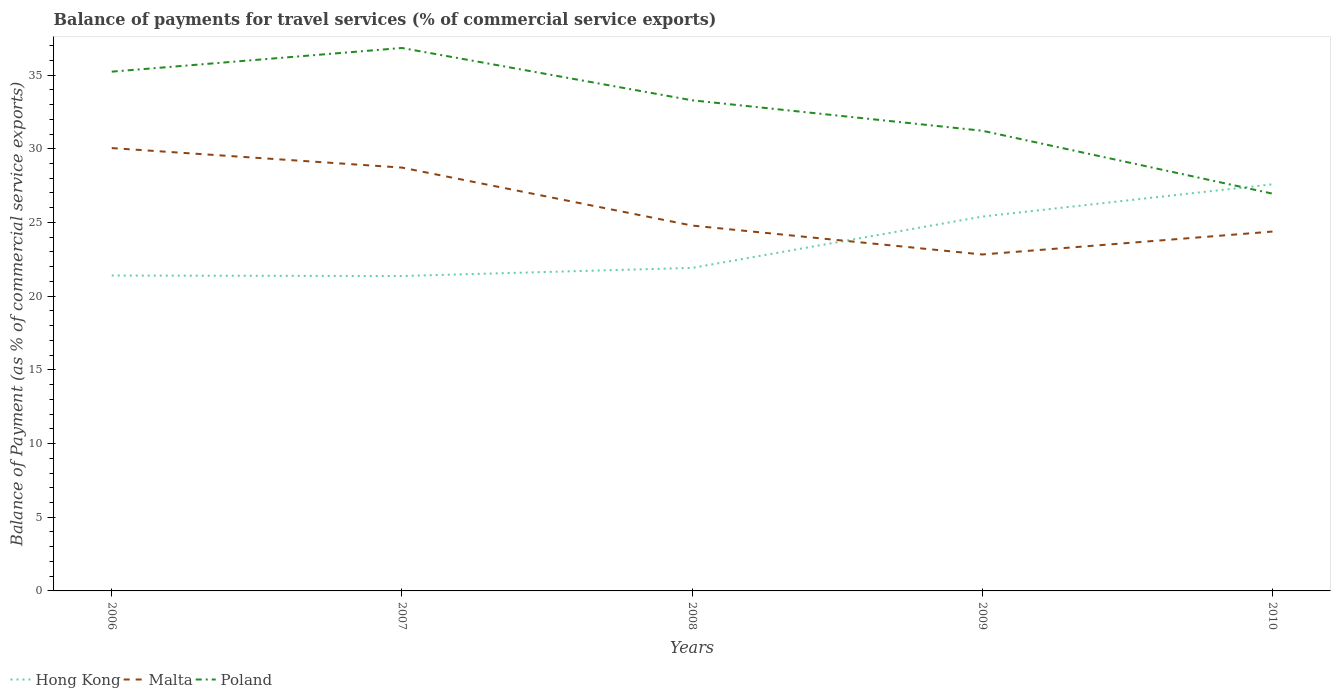Across all years, what is the maximum balance of payments for travel services in Malta?
Offer a very short reply. 22.83. In which year was the balance of payments for travel services in Poland maximum?
Provide a short and direct response. 2010. What is the total balance of payments for travel services in Hong Kong in the graph?
Give a very brief answer. 0.03. What is the difference between the highest and the second highest balance of payments for travel services in Hong Kong?
Provide a short and direct response. 6.22. Is the balance of payments for travel services in Hong Kong strictly greater than the balance of payments for travel services in Malta over the years?
Provide a short and direct response. No. How many lines are there?
Your answer should be very brief. 3. How many years are there in the graph?
Keep it short and to the point. 5. Are the values on the major ticks of Y-axis written in scientific E-notation?
Keep it short and to the point. No. Does the graph contain any zero values?
Your response must be concise. No. Where does the legend appear in the graph?
Ensure brevity in your answer.  Bottom left. How many legend labels are there?
Provide a succinct answer. 3. How are the legend labels stacked?
Provide a succinct answer. Horizontal. What is the title of the graph?
Keep it short and to the point. Balance of payments for travel services (% of commercial service exports). Does "Isle of Man" appear as one of the legend labels in the graph?
Offer a terse response. No. What is the label or title of the X-axis?
Offer a terse response. Years. What is the label or title of the Y-axis?
Provide a succinct answer. Balance of Payment (as % of commercial service exports). What is the Balance of Payment (as % of commercial service exports) of Hong Kong in 2006?
Give a very brief answer. 21.4. What is the Balance of Payment (as % of commercial service exports) of Malta in 2006?
Offer a very short reply. 30.05. What is the Balance of Payment (as % of commercial service exports) of Poland in 2006?
Your response must be concise. 35.23. What is the Balance of Payment (as % of commercial service exports) in Hong Kong in 2007?
Your response must be concise. 21.37. What is the Balance of Payment (as % of commercial service exports) of Malta in 2007?
Provide a succinct answer. 28.72. What is the Balance of Payment (as % of commercial service exports) in Poland in 2007?
Give a very brief answer. 36.84. What is the Balance of Payment (as % of commercial service exports) in Hong Kong in 2008?
Your answer should be compact. 21.92. What is the Balance of Payment (as % of commercial service exports) in Malta in 2008?
Offer a very short reply. 24.79. What is the Balance of Payment (as % of commercial service exports) in Poland in 2008?
Offer a terse response. 33.29. What is the Balance of Payment (as % of commercial service exports) in Hong Kong in 2009?
Provide a succinct answer. 25.4. What is the Balance of Payment (as % of commercial service exports) of Malta in 2009?
Ensure brevity in your answer.  22.83. What is the Balance of Payment (as % of commercial service exports) in Poland in 2009?
Make the answer very short. 31.22. What is the Balance of Payment (as % of commercial service exports) of Hong Kong in 2010?
Make the answer very short. 27.59. What is the Balance of Payment (as % of commercial service exports) in Malta in 2010?
Your response must be concise. 24.38. What is the Balance of Payment (as % of commercial service exports) of Poland in 2010?
Offer a terse response. 26.95. Across all years, what is the maximum Balance of Payment (as % of commercial service exports) of Hong Kong?
Keep it short and to the point. 27.59. Across all years, what is the maximum Balance of Payment (as % of commercial service exports) of Malta?
Give a very brief answer. 30.05. Across all years, what is the maximum Balance of Payment (as % of commercial service exports) of Poland?
Ensure brevity in your answer.  36.84. Across all years, what is the minimum Balance of Payment (as % of commercial service exports) of Hong Kong?
Provide a succinct answer. 21.37. Across all years, what is the minimum Balance of Payment (as % of commercial service exports) in Malta?
Make the answer very short. 22.83. Across all years, what is the minimum Balance of Payment (as % of commercial service exports) of Poland?
Your response must be concise. 26.95. What is the total Balance of Payment (as % of commercial service exports) in Hong Kong in the graph?
Give a very brief answer. 117.67. What is the total Balance of Payment (as % of commercial service exports) of Malta in the graph?
Your answer should be compact. 130.76. What is the total Balance of Payment (as % of commercial service exports) in Poland in the graph?
Make the answer very short. 163.54. What is the difference between the Balance of Payment (as % of commercial service exports) of Hong Kong in 2006 and that in 2007?
Provide a short and direct response. 0.03. What is the difference between the Balance of Payment (as % of commercial service exports) in Malta in 2006 and that in 2007?
Provide a short and direct response. 1.32. What is the difference between the Balance of Payment (as % of commercial service exports) of Poland in 2006 and that in 2007?
Give a very brief answer. -1.61. What is the difference between the Balance of Payment (as % of commercial service exports) of Hong Kong in 2006 and that in 2008?
Your response must be concise. -0.52. What is the difference between the Balance of Payment (as % of commercial service exports) in Malta in 2006 and that in 2008?
Keep it short and to the point. 5.26. What is the difference between the Balance of Payment (as % of commercial service exports) of Poland in 2006 and that in 2008?
Offer a very short reply. 1.94. What is the difference between the Balance of Payment (as % of commercial service exports) of Hong Kong in 2006 and that in 2009?
Your answer should be very brief. -4. What is the difference between the Balance of Payment (as % of commercial service exports) in Malta in 2006 and that in 2009?
Provide a succinct answer. 7.22. What is the difference between the Balance of Payment (as % of commercial service exports) of Poland in 2006 and that in 2009?
Keep it short and to the point. 4.01. What is the difference between the Balance of Payment (as % of commercial service exports) in Hong Kong in 2006 and that in 2010?
Keep it short and to the point. -6.19. What is the difference between the Balance of Payment (as % of commercial service exports) in Malta in 2006 and that in 2010?
Offer a very short reply. 5.66. What is the difference between the Balance of Payment (as % of commercial service exports) in Poland in 2006 and that in 2010?
Give a very brief answer. 8.28. What is the difference between the Balance of Payment (as % of commercial service exports) in Hong Kong in 2007 and that in 2008?
Make the answer very short. -0.55. What is the difference between the Balance of Payment (as % of commercial service exports) in Malta in 2007 and that in 2008?
Your answer should be compact. 3.93. What is the difference between the Balance of Payment (as % of commercial service exports) of Poland in 2007 and that in 2008?
Your response must be concise. 3.55. What is the difference between the Balance of Payment (as % of commercial service exports) of Hong Kong in 2007 and that in 2009?
Give a very brief answer. -4.03. What is the difference between the Balance of Payment (as % of commercial service exports) of Malta in 2007 and that in 2009?
Make the answer very short. 5.9. What is the difference between the Balance of Payment (as % of commercial service exports) in Poland in 2007 and that in 2009?
Provide a short and direct response. 5.61. What is the difference between the Balance of Payment (as % of commercial service exports) in Hong Kong in 2007 and that in 2010?
Give a very brief answer. -6.22. What is the difference between the Balance of Payment (as % of commercial service exports) in Malta in 2007 and that in 2010?
Your response must be concise. 4.34. What is the difference between the Balance of Payment (as % of commercial service exports) of Poland in 2007 and that in 2010?
Your answer should be very brief. 9.88. What is the difference between the Balance of Payment (as % of commercial service exports) of Hong Kong in 2008 and that in 2009?
Ensure brevity in your answer.  -3.48. What is the difference between the Balance of Payment (as % of commercial service exports) in Malta in 2008 and that in 2009?
Ensure brevity in your answer.  1.96. What is the difference between the Balance of Payment (as % of commercial service exports) in Poland in 2008 and that in 2009?
Make the answer very short. 2.06. What is the difference between the Balance of Payment (as % of commercial service exports) of Hong Kong in 2008 and that in 2010?
Provide a succinct answer. -5.67. What is the difference between the Balance of Payment (as % of commercial service exports) of Malta in 2008 and that in 2010?
Provide a short and direct response. 0.41. What is the difference between the Balance of Payment (as % of commercial service exports) in Poland in 2008 and that in 2010?
Ensure brevity in your answer.  6.33. What is the difference between the Balance of Payment (as % of commercial service exports) of Hong Kong in 2009 and that in 2010?
Offer a terse response. -2.19. What is the difference between the Balance of Payment (as % of commercial service exports) in Malta in 2009 and that in 2010?
Offer a terse response. -1.55. What is the difference between the Balance of Payment (as % of commercial service exports) in Poland in 2009 and that in 2010?
Provide a short and direct response. 4.27. What is the difference between the Balance of Payment (as % of commercial service exports) in Hong Kong in 2006 and the Balance of Payment (as % of commercial service exports) in Malta in 2007?
Your answer should be compact. -7.32. What is the difference between the Balance of Payment (as % of commercial service exports) of Hong Kong in 2006 and the Balance of Payment (as % of commercial service exports) of Poland in 2007?
Give a very brief answer. -15.44. What is the difference between the Balance of Payment (as % of commercial service exports) of Malta in 2006 and the Balance of Payment (as % of commercial service exports) of Poland in 2007?
Make the answer very short. -6.79. What is the difference between the Balance of Payment (as % of commercial service exports) in Hong Kong in 2006 and the Balance of Payment (as % of commercial service exports) in Malta in 2008?
Give a very brief answer. -3.39. What is the difference between the Balance of Payment (as % of commercial service exports) of Hong Kong in 2006 and the Balance of Payment (as % of commercial service exports) of Poland in 2008?
Keep it short and to the point. -11.89. What is the difference between the Balance of Payment (as % of commercial service exports) in Malta in 2006 and the Balance of Payment (as % of commercial service exports) in Poland in 2008?
Provide a short and direct response. -3.24. What is the difference between the Balance of Payment (as % of commercial service exports) of Hong Kong in 2006 and the Balance of Payment (as % of commercial service exports) of Malta in 2009?
Your answer should be very brief. -1.43. What is the difference between the Balance of Payment (as % of commercial service exports) in Hong Kong in 2006 and the Balance of Payment (as % of commercial service exports) in Poland in 2009?
Your answer should be very brief. -9.82. What is the difference between the Balance of Payment (as % of commercial service exports) of Malta in 2006 and the Balance of Payment (as % of commercial service exports) of Poland in 2009?
Make the answer very short. -1.18. What is the difference between the Balance of Payment (as % of commercial service exports) of Hong Kong in 2006 and the Balance of Payment (as % of commercial service exports) of Malta in 2010?
Offer a terse response. -2.98. What is the difference between the Balance of Payment (as % of commercial service exports) of Hong Kong in 2006 and the Balance of Payment (as % of commercial service exports) of Poland in 2010?
Make the answer very short. -5.56. What is the difference between the Balance of Payment (as % of commercial service exports) of Malta in 2006 and the Balance of Payment (as % of commercial service exports) of Poland in 2010?
Your answer should be compact. 3.09. What is the difference between the Balance of Payment (as % of commercial service exports) of Hong Kong in 2007 and the Balance of Payment (as % of commercial service exports) of Malta in 2008?
Make the answer very short. -3.42. What is the difference between the Balance of Payment (as % of commercial service exports) of Hong Kong in 2007 and the Balance of Payment (as % of commercial service exports) of Poland in 2008?
Keep it short and to the point. -11.92. What is the difference between the Balance of Payment (as % of commercial service exports) of Malta in 2007 and the Balance of Payment (as % of commercial service exports) of Poland in 2008?
Your response must be concise. -4.57. What is the difference between the Balance of Payment (as % of commercial service exports) in Hong Kong in 2007 and the Balance of Payment (as % of commercial service exports) in Malta in 2009?
Your response must be concise. -1.46. What is the difference between the Balance of Payment (as % of commercial service exports) of Hong Kong in 2007 and the Balance of Payment (as % of commercial service exports) of Poland in 2009?
Offer a very short reply. -9.86. What is the difference between the Balance of Payment (as % of commercial service exports) in Malta in 2007 and the Balance of Payment (as % of commercial service exports) in Poland in 2009?
Ensure brevity in your answer.  -2.5. What is the difference between the Balance of Payment (as % of commercial service exports) in Hong Kong in 2007 and the Balance of Payment (as % of commercial service exports) in Malta in 2010?
Your response must be concise. -3.02. What is the difference between the Balance of Payment (as % of commercial service exports) in Hong Kong in 2007 and the Balance of Payment (as % of commercial service exports) in Poland in 2010?
Keep it short and to the point. -5.59. What is the difference between the Balance of Payment (as % of commercial service exports) in Malta in 2007 and the Balance of Payment (as % of commercial service exports) in Poland in 2010?
Your response must be concise. 1.77. What is the difference between the Balance of Payment (as % of commercial service exports) in Hong Kong in 2008 and the Balance of Payment (as % of commercial service exports) in Malta in 2009?
Provide a succinct answer. -0.91. What is the difference between the Balance of Payment (as % of commercial service exports) of Hong Kong in 2008 and the Balance of Payment (as % of commercial service exports) of Poland in 2009?
Offer a very short reply. -9.31. What is the difference between the Balance of Payment (as % of commercial service exports) in Malta in 2008 and the Balance of Payment (as % of commercial service exports) in Poland in 2009?
Provide a succinct answer. -6.43. What is the difference between the Balance of Payment (as % of commercial service exports) in Hong Kong in 2008 and the Balance of Payment (as % of commercial service exports) in Malta in 2010?
Offer a terse response. -2.46. What is the difference between the Balance of Payment (as % of commercial service exports) in Hong Kong in 2008 and the Balance of Payment (as % of commercial service exports) in Poland in 2010?
Your answer should be very brief. -5.04. What is the difference between the Balance of Payment (as % of commercial service exports) of Malta in 2008 and the Balance of Payment (as % of commercial service exports) of Poland in 2010?
Offer a very short reply. -2.17. What is the difference between the Balance of Payment (as % of commercial service exports) in Hong Kong in 2009 and the Balance of Payment (as % of commercial service exports) in Malta in 2010?
Offer a very short reply. 1.02. What is the difference between the Balance of Payment (as % of commercial service exports) in Hong Kong in 2009 and the Balance of Payment (as % of commercial service exports) in Poland in 2010?
Offer a very short reply. -1.56. What is the difference between the Balance of Payment (as % of commercial service exports) of Malta in 2009 and the Balance of Payment (as % of commercial service exports) of Poland in 2010?
Your response must be concise. -4.13. What is the average Balance of Payment (as % of commercial service exports) in Hong Kong per year?
Your answer should be very brief. 23.53. What is the average Balance of Payment (as % of commercial service exports) in Malta per year?
Provide a succinct answer. 26.15. What is the average Balance of Payment (as % of commercial service exports) of Poland per year?
Your answer should be compact. 32.71. In the year 2006, what is the difference between the Balance of Payment (as % of commercial service exports) in Hong Kong and Balance of Payment (as % of commercial service exports) in Malta?
Keep it short and to the point. -8.65. In the year 2006, what is the difference between the Balance of Payment (as % of commercial service exports) of Hong Kong and Balance of Payment (as % of commercial service exports) of Poland?
Your answer should be compact. -13.83. In the year 2006, what is the difference between the Balance of Payment (as % of commercial service exports) of Malta and Balance of Payment (as % of commercial service exports) of Poland?
Provide a short and direct response. -5.19. In the year 2007, what is the difference between the Balance of Payment (as % of commercial service exports) of Hong Kong and Balance of Payment (as % of commercial service exports) of Malta?
Your answer should be compact. -7.36. In the year 2007, what is the difference between the Balance of Payment (as % of commercial service exports) in Hong Kong and Balance of Payment (as % of commercial service exports) in Poland?
Offer a terse response. -15.47. In the year 2007, what is the difference between the Balance of Payment (as % of commercial service exports) in Malta and Balance of Payment (as % of commercial service exports) in Poland?
Your response must be concise. -8.12. In the year 2008, what is the difference between the Balance of Payment (as % of commercial service exports) in Hong Kong and Balance of Payment (as % of commercial service exports) in Malta?
Make the answer very short. -2.87. In the year 2008, what is the difference between the Balance of Payment (as % of commercial service exports) of Hong Kong and Balance of Payment (as % of commercial service exports) of Poland?
Provide a succinct answer. -11.37. In the year 2008, what is the difference between the Balance of Payment (as % of commercial service exports) in Malta and Balance of Payment (as % of commercial service exports) in Poland?
Provide a short and direct response. -8.5. In the year 2009, what is the difference between the Balance of Payment (as % of commercial service exports) of Hong Kong and Balance of Payment (as % of commercial service exports) of Malta?
Provide a succinct answer. 2.57. In the year 2009, what is the difference between the Balance of Payment (as % of commercial service exports) in Hong Kong and Balance of Payment (as % of commercial service exports) in Poland?
Give a very brief answer. -5.82. In the year 2009, what is the difference between the Balance of Payment (as % of commercial service exports) in Malta and Balance of Payment (as % of commercial service exports) in Poland?
Your response must be concise. -8.4. In the year 2010, what is the difference between the Balance of Payment (as % of commercial service exports) in Hong Kong and Balance of Payment (as % of commercial service exports) in Malta?
Make the answer very short. 3.21. In the year 2010, what is the difference between the Balance of Payment (as % of commercial service exports) in Hong Kong and Balance of Payment (as % of commercial service exports) in Poland?
Keep it short and to the point. 0.63. In the year 2010, what is the difference between the Balance of Payment (as % of commercial service exports) in Malta and Balance of Payment (as % of commercial service exports) in Poland?
Make the answer very short. -2.57. What is the ratio of the Balance of Payment (as % of commercial service exports) in Hong Kong in 2006 to that in 2007?
Make the answer very short. 1. What is the ratio of the Balance of Payment (as % of commercial service exports) of Malta in 2006 to that in 2007?
Offer a terse response. 1.05. What is the ratio of the Balance of Payment (as % of commercial service exports) of Poland in 2006 to that in 2007?
Your answer should be very brief. 0.96. What is the ratio of the Balance of Payment (as % of commercial service exports) in Hong Kong in 2006 to that in 2008?
Provide a short and direct response. 0.98. What is the ratio of the Balance of Payment (as % of commercial service exports) in Malta in 2006 to that in 2008?
Your answer should be compact. 1.21. What is the ratio of the Balance of Payment (as % of commercial service exports) in Poland in 2006 to that in 2008?
Offer a very short reply. 1.06. What is the ratio of the Balance of Payment (as % of commercial service exports) in Hong Kong in 2006 to that in 2009?
Provide a short and direct response. 0.84. What is the ratio of the Balance of Payment (as % of commercial service exports) of Malta in 2006 to that in 2009?
Your answer should be compact. 1.32. What is the ratio of the Balance of Payment (as % of commercial service exports) of Poland in 2006 to that in 2009?
Your answer should be very brief. 1.13. What is the ratio of the Balance of Payment (as % of commercial service exports) in Hong Kong in 2006 to that in 2010?
Ensure brevity in your answer.  0.78. What is the ratio of the Balance of Payment (as % of commercial service exports) of Malta in 2006 to that in 2010?
Provide a succinct answer. 1.23. What is the ratio of the Balance of Payment (as % of commercial service exports) in Poland in 2006 to that in 2010?
Keep it short and to the point. 1.31. What is the ratio of the Balance of Payment (as % of commercial service exports) in Hong Kong in 2007 to that in 2008?
Give a very brief answer. 0.97. What is the ratio of the Balance of Payment (as % of commercial service exports) in Malta in 2007 to that in 2008?
Give a very brief answer. 1.16. What is the ratio of the Balance of Payment (as % of commercial service exports) of Poland in 2007 to that in 2008?
Your response must be concise. 1.11. What is the ratio of the Balance of Payment (as % of commercial service exports) in Hong Kong in 2007 to that in 2009?
Provide a short and direct response. 0.84. What is the ratio of the Balance of Payment (as % of commercial service exports) in Malta in 2007 to that in 2009?
Ensure brevity in your answer.  1.26. What is the ratio of the Balance of Payment (as % of commercial service exports) in Poland in 2007 to that in 2009?
Make the answer very short. 1.18. What is the ratio of the Balance of Payment (as % of commercial service exports) in Hong Kong in 2007 to that in 2010?
Your answer should be very brief. 0.77. What is the ratio of the Balance of Payment (as % of commercial service exports) of Malta in 2007 to that in 2010?
Ensure brevity in your answer.  1.18. What is the ratio of the Balance of Payment (as % of commercial service exports) in Poland in 2007 to that in 2010?
Provide a short and direct response. 1.37. What is the ratio of the Balance of Payment (as % of commercial service exports) in Hong Kong in 2008 to that in 2009?
Provide a succinct answer. 0.86. What is the ratio of the Balance of Payment (as % of commercial service exports) of Malta in 2008 to that in 2009?
Ensure brevity in your answer.  1.09. What is the ratio of the Balance of Payment (as % of commercial service exports) in Poland in 2008 to that in 2009?
Your response must be concise. 1.07. What is the ratio of the Balance of Payment (as % of commercial service exports) in Hong Kong in 2008 to that in 2010?
Provide a succinct answer. 0.79. What is the ratio of the Balance of Payment (as % of commercial service exports) of Malta in 2008 to that in 2010?
Your answer should be compact. 1.02. What is the ratio of the Balance of Payment (as % of commercial service exports) of Poland in 2008 to that in 2010?
Make the answer very short. 1.24. What is the ratio of the Balance of Payment (as % of commercial service exports) in Hong Kong in 2009 to that in 2010?
Your response must be concise. 0.92. What is the ratio of the Balance of Payment (as % of commercial service exports) of Malta in 2009 to that in 2010?
Keep it short and to the point. 0.94. What is the ratio of the Balance of Payment (as % of commercial service exports) of Poland in 2009 to that in 2010?
Your response must be concise. 1.16. What is the difference between the highest and the second highest Balance of Payment (as % of commercial service exports) in Hong Kong?
Make the answer very short. 2.19. What is the difference between the highest and the second highest Balance of Payment (as % of commercial service exports) in Malta?
Your answer should be very brief. 1.32. What is the difference between the highest and the second highest Balance of Payment (as % of commercial service exports) in Poland?
Offer a very short reply. 1.61. What is the difference between the highest and the lowest Balance of Payment (as % of commercial service exports) of Hong Kong?
Your response must be concise. 6.22. What is the difference between the highest and the lowest Balance of Payment (as % of commercial service exports) in Malta?
Offer a very short reply. 7.22. What is the difference between the highest and the lowest Balance of Payment (as % of commercial service exports) in Poland?
Your answer should be compact. 9.88. 